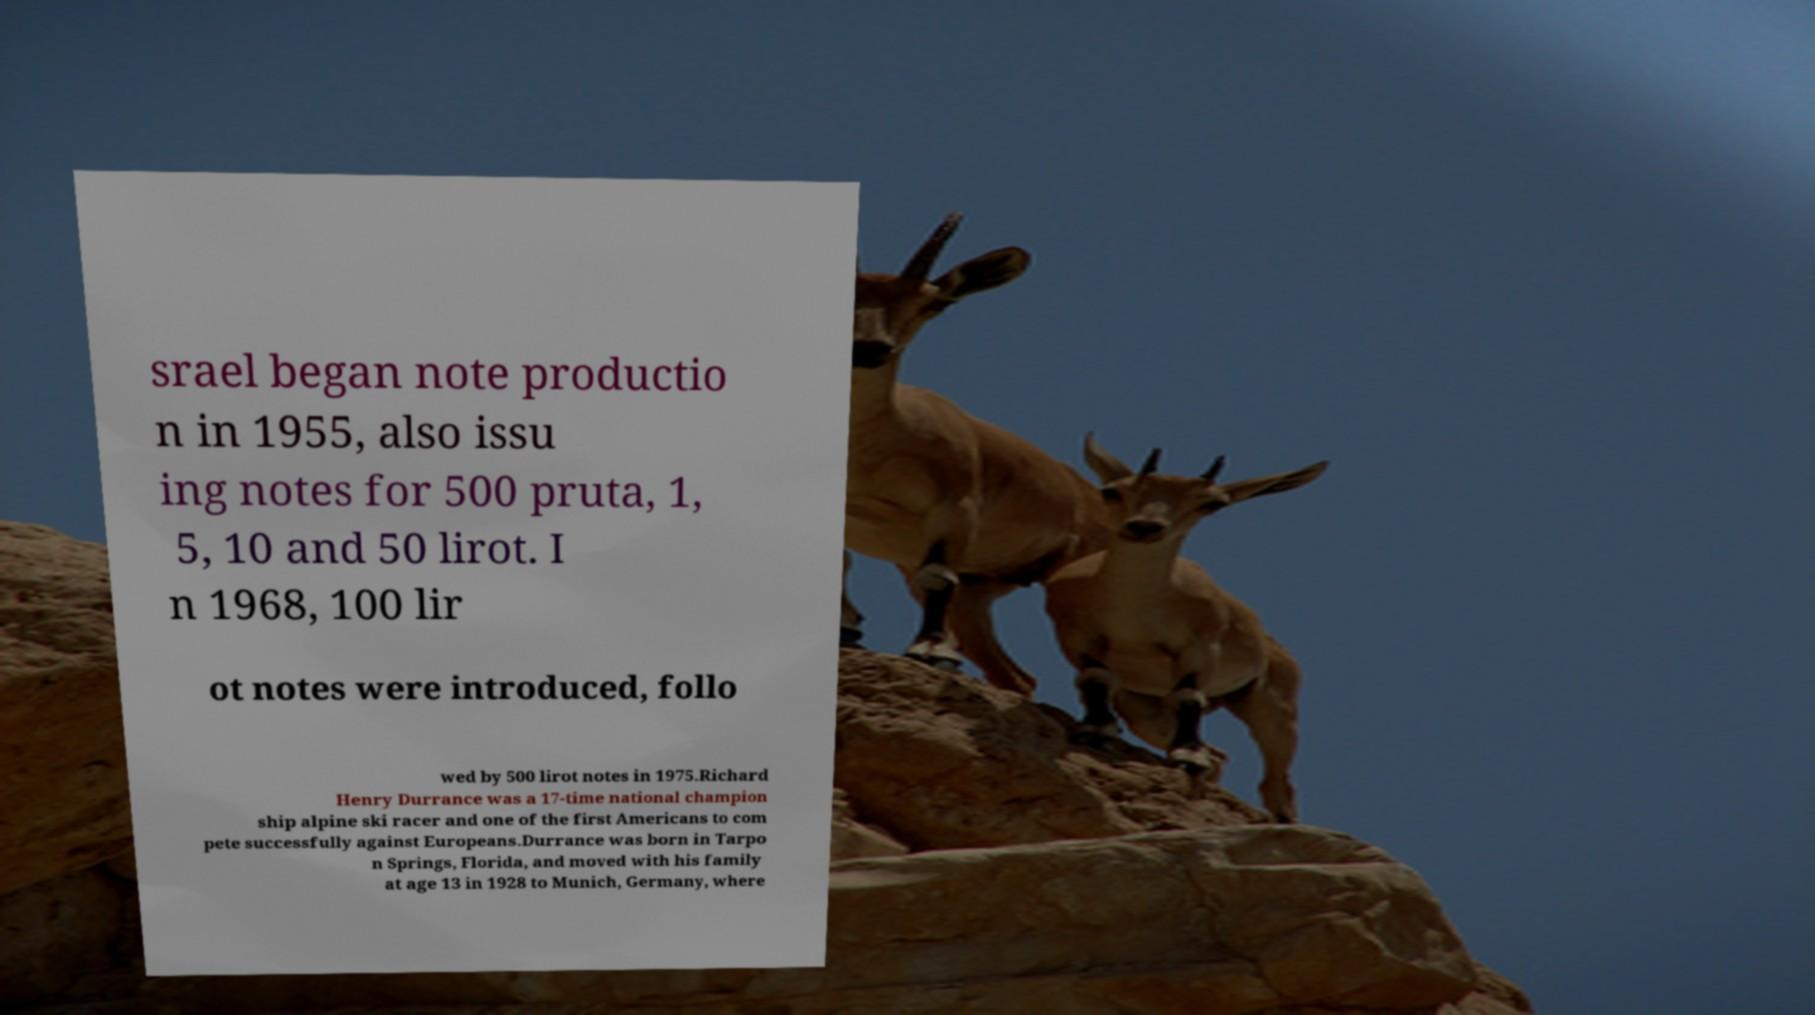There's text embedded in this image that I need extracted. Can you transcribe it verbatim? srael began note productio n in 1955, also issu ing notes for 500 pruta, 1, 5, 10 and 50 lirot. I n 1968, 100 lir ot notes were introduced, follo wed by 500 lirot notes in 1975.Richard Henry Durrance was a 17-time national champion ship alpine ski racer and one of the first Americans to com pete successfully against Europeans.Durrance was born in Tarpo n Springs, Florida, and moved with his family at age 13 in 1928 to Munich, Germany, where 